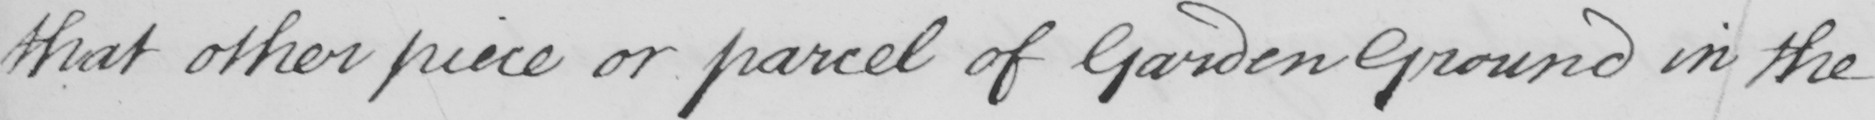Can you tell me what this handwritten text says? that other piece or parcel of Garden Ground in the 